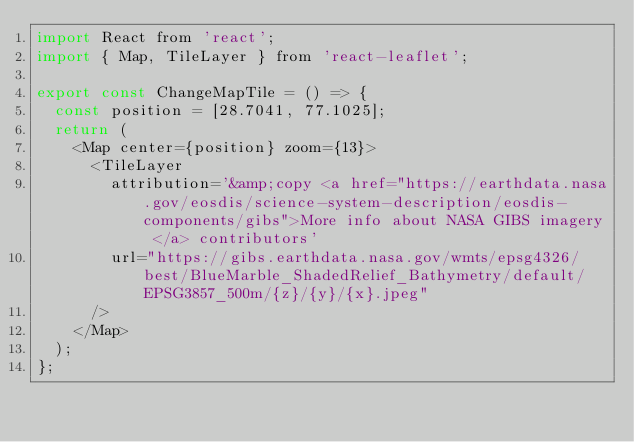Convert code to text. <code><loc_0><loc_0><loc_500><loc_500><_JavaScript_>import React from 'react';
import { Map, TileLayer } from 'react-leaflet';

export const ChangeMapTile = () => {
  const position = [28.7041, 77.1025];
  return (
    <Map center={position} zoom={13}>
      <TileLayer
        attribution='&amp;copy <a href="https://earthdata.nasa.gov/eosdis/science-system-description/eosdis-components/gibs">More info about NASA GIBS imagery </a> contributors'
        url="https://gibs.earthdata.nasa.gov/wmts/epsg4326/best/BlueMarble_ShadedRelief_Bathymetry/default/EPSG3857_500m/{z}/{y}/{x}.jpeg"
      />
    </Map>
  );
};
</code> 